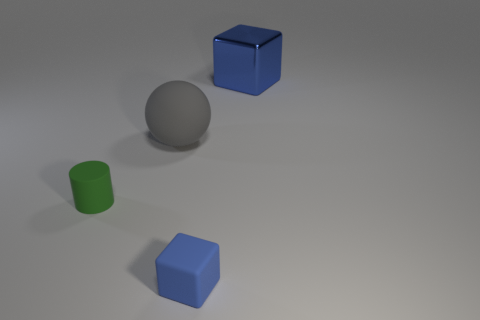Add 2 big blue metal blocks. How many objects exist? 6 Subtract all spheres. How many objects are left? 3 Add 4 metallic things. How many metallic things are left? 5 Add 2 big gray matte balls. How many big gray matte balls exist? 3 Subtract 0 gray blocks. How many objects are left? 4 Subtract all small red metal balls. Subtract all blue things. How many objects are left? 2 